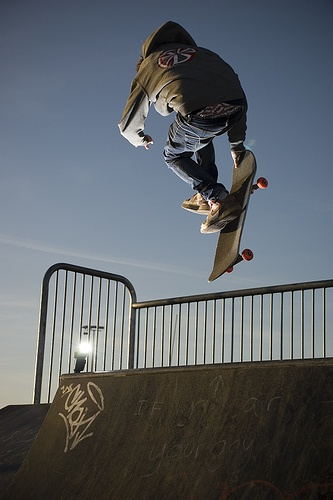Describe the objects in this image and their specific colors. I can see people in black, gray, and darkgray tones and skateboard in black, gray, and maroon tones in this image. 